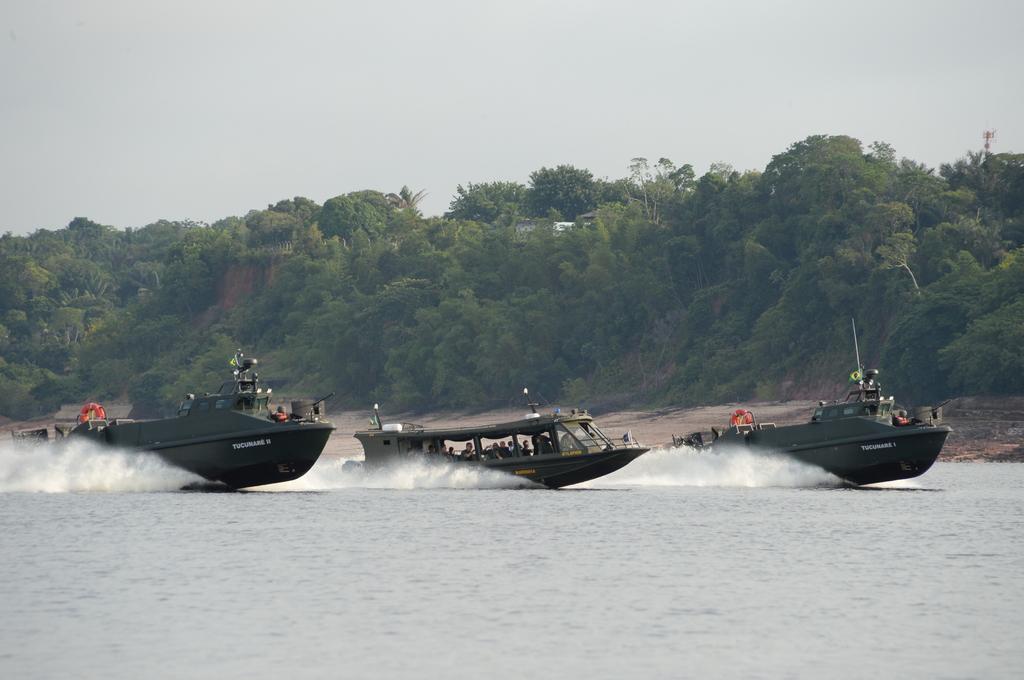Can you describe this image briefly? In this picture there are three boats on the water. In the boats we can see the group of persons were sitting. In the background we can see building. At the top we can see sky and clouds. 